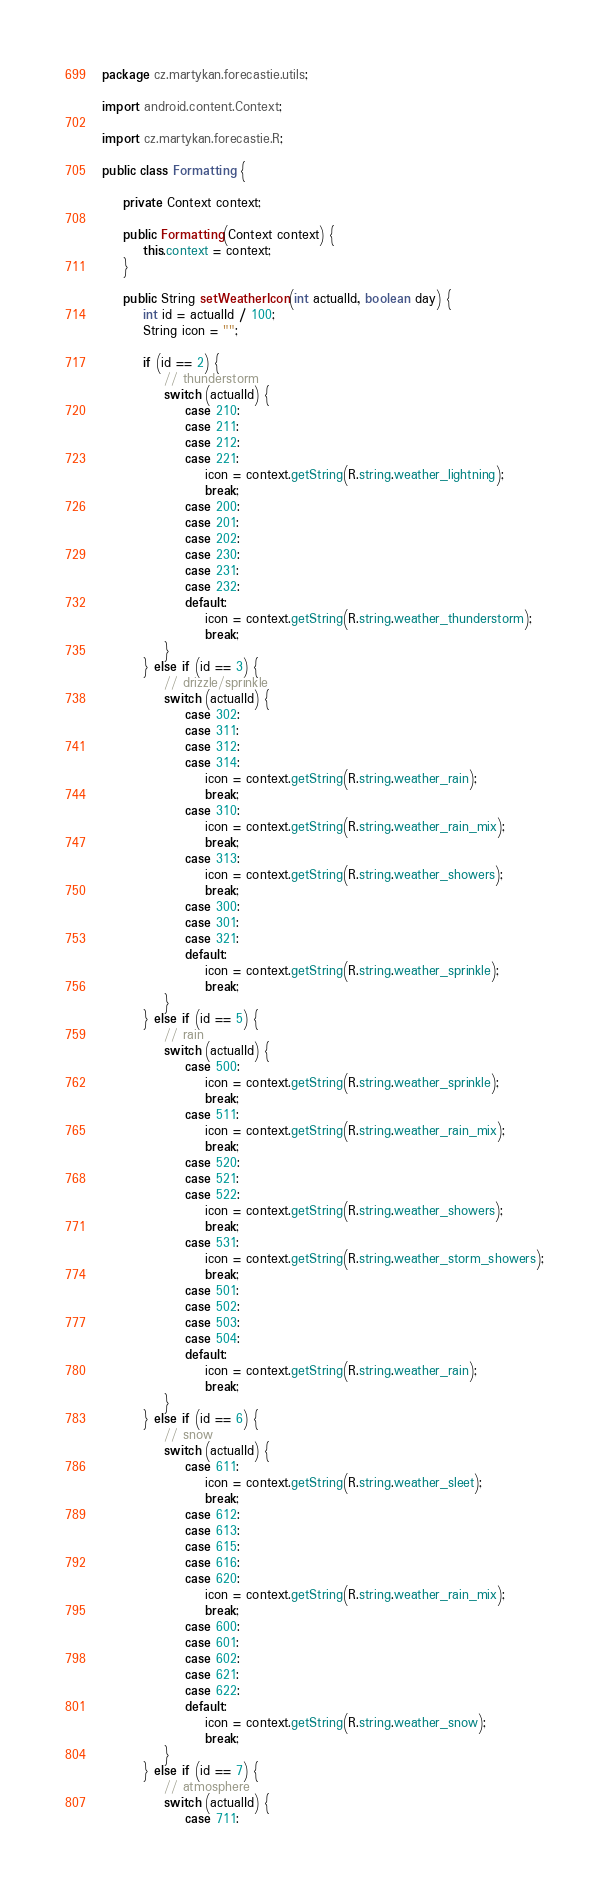Convert code to text. <code><loc_0><loc_0><loc_500><loc_500><_Java_>package cz.martykan.forecastie.utils;

import android.content.Context;

import cz.martykan.forecastie.R;

public class Formatting {

    private Context context;

    public Formatting(Context context) {
        this.context = context;
    }

    public String setWeatherIcon(int actualId, boolean day) {
        int id = actualId / 100;
        String icon = "";

        if (id == 2) {
            // thunderstorm
            switch (actualId) {
                case 210:
                case 211:
                case 212:
                case 221:
                    icon = context.getString(R.string.weather_lightning);
                    break;
                case 200:
                case 201:
                case 202:
                case 230:
                case 231:
                case 232:
                default:
                    icon = context.getString(R.string.weather_thunderstorm);
                    break;
            }
        } else if (id == 3) {
            // drizzle/sprinkle
            switch (actualId) {
                case 302:
                case 311:
                case 312:
                case 314:
                    icon = context.getString(R.string.weather_rain);
                    break;
                case 310:
                    icon = context.getString(R.string.weather_rain_mix);
                    break;
                case 313:
                    icon = context.getString(R.string.weather_showers);
                    break;
                case 300:
                case 301:
                case 321:
                default:
                    icon = context.getString(R.string.weather_sprinkle);
                    break;
            }
        } else if (id == 5) {
            // rain
            switch (actualId) {
                case 500:
                    icon = context.getString(R.string.weather_sprinkle);
                    break;
                case 511:
                    icon = context.getString(R.string.weather_rain_mix);
                    break;
                case 520:
                case 521:
                case 522:
                    icon = context.getString(R.string.weather_showers);
                    break;
                case 531:
                    icon = context.getString(R.string.weather_storm_showers);
                    break;
                case 501:
                case 502:
                case 503:
                case 504:
                default:
                    icon = context.getString(R.string.weather_rain);
                    break;
            }
        } else if (id == 6) {
            // snow
            switch (actualId) {
                case 611:
                    icon = context.getString(R.string.weather_sleet);
                    break;
                case 612:
                case 613:
                case 615:
                case 616:
                case 620:
                    icon = context.getString(R.string.weather_rain_mix);
                    break;
                case 600:
                case 601:
                case 602:
                case 621:
                case 622:
                default:
                    icon = context.getString(R.string.weather_snow);
                    break;
            }
        } else if (id == 7) {
            // atmosphere
            switch (actualId) {
                case 711:</code> 